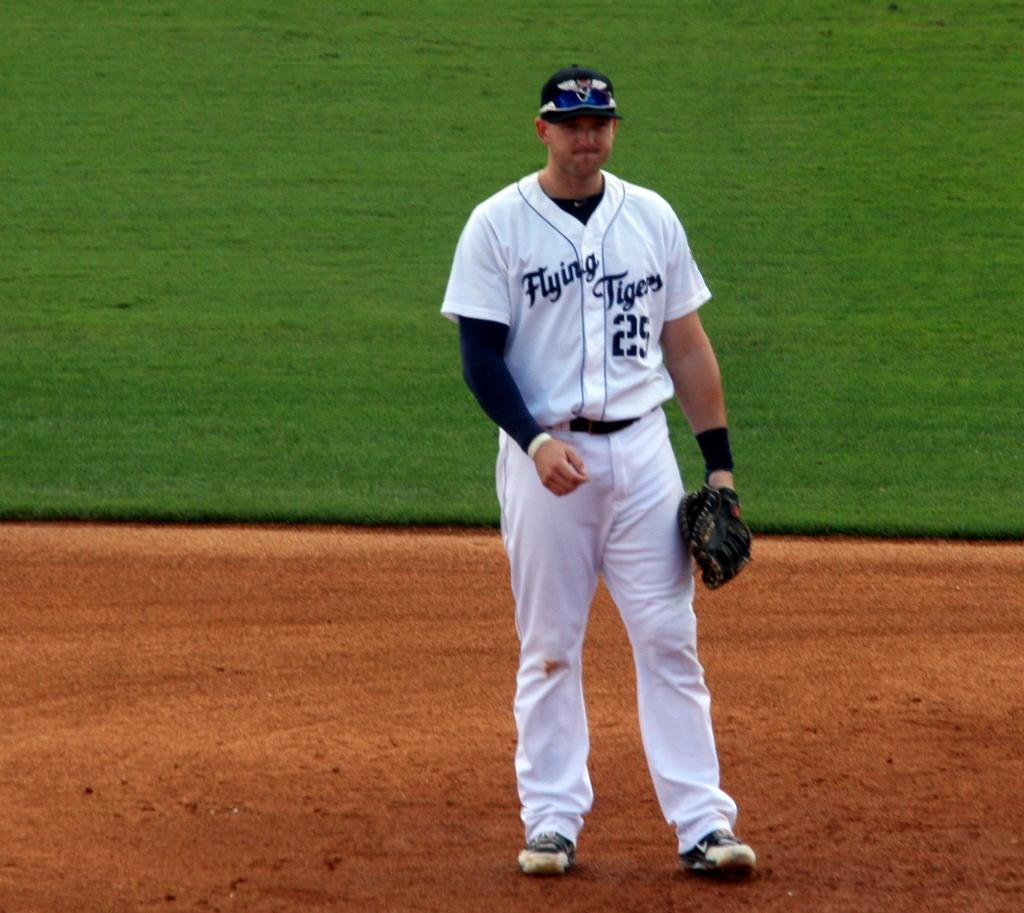<image>
Present a compact description of the photo's key features. A baseball player in white with flting tigers and the number 25 looks forlorn on the field. 